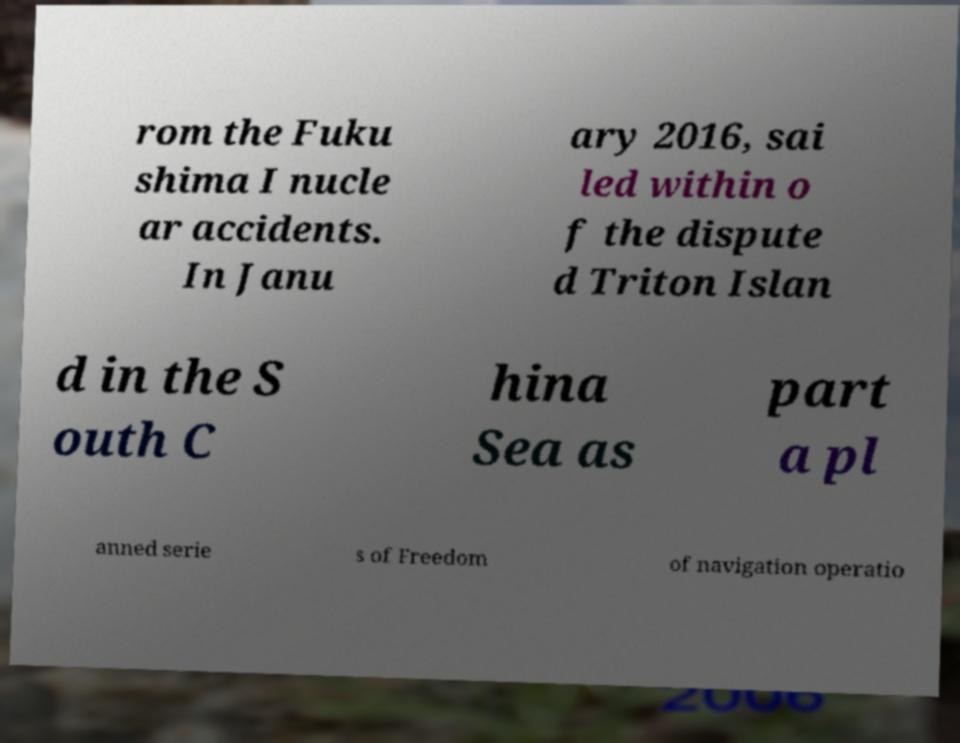I need the written content from this picture converted into text. Can you do that? rom the Fuku shima I nucle ar accidents. In Janu ary 2016, sai led within o f the dispute d Triton Islan d in the S outh C hina Sea as part a pl anned serie s of Freedom of navigation operatio 